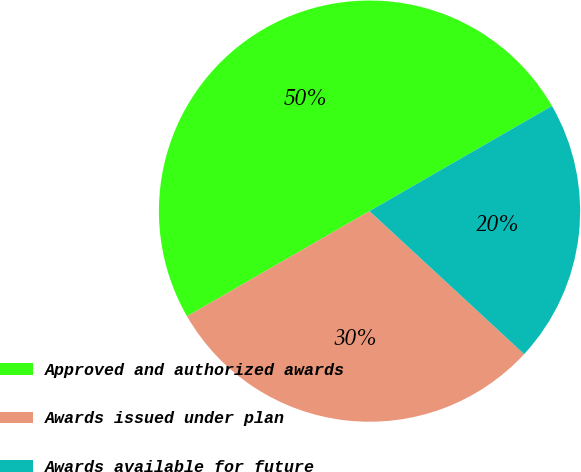<chart> <loc_0><loc_0><loc_500><loc_500><pie_chart><fcel>Approved and authorized awards<fcel>Awards issued under plan<fcel>Awards available for future<nl><fcel>50.0%<fcel>29.8%<fcel>20.2%<nl></chart> 